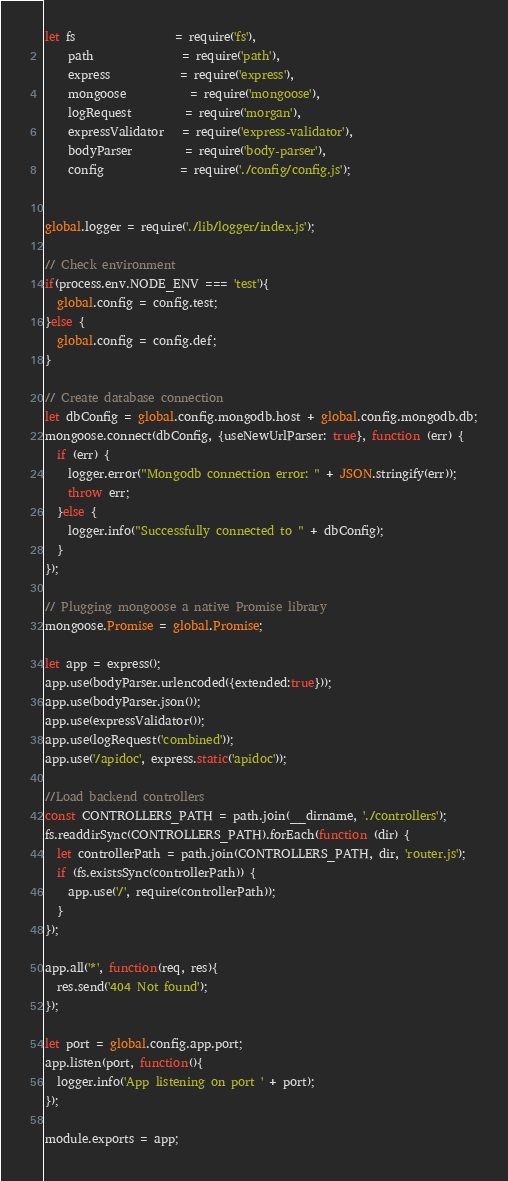Convert code to text. <code><loc_0><loc_0><loc_500><loc_500><_JavaScript_>let fs                 = require('fs'),
    path               = require('path'),
    express            = require('express'),
    mongoose           = require('mongoose'),
    logRequest         = require('morgan'),
    expressValidator   = require('express-validator'),
    bodyParser         = require('body-parser'),
    config             = require('./config/config.js');


global.logger = require('./lib/logger/index.js');

// Check environment
if(process.env.NODE_ENV === 'test'){
  global.config = config.test;
}else {
  global.config = config.def;
}

// Create database connection
let dbConfig = global.config.mongodb.host + global.config.mongodb.db;
mongoose.connect(dbConfig, {useNewUrlParser: true}, function (err) {
  if (err) {
    logger.error("Mongodb connection error: " + JSON.stringify(err));
    throw err;
  }else {
    logger.info("Successfully connected to " + dbConfig);
  }
});

// Plugging mongoose a native Promise library
mongoose.Promise = global.Promise;

let app = express();
app.use(bodyParser.urlencoded({extended:true}));
app.use(bodyParser.json());
app.use(expressValidator());
app.use(logRequest('combined'));
app.use('/apidoc', express.static('apidoc'));

//Load backend controllers
const CONTROLLERS_PATH = path.join(__dirname, './controllers');
fs.readdirSync(CONTROLLERS_PATH).forEach(function (dir) {
  let controllerPath = path.join(CONTROLLERS_PATH, dir, 'router.js');
  if (fs.existsSync(controllerPath)) {
    app.use('/', require(controllerPath));
  }
});

app.all('*', function(req, res){
  res.send('404 Not found');
});

let port = global.config.app.port;
app.listen(port, function(){
  logger.info('App listening on port ' + port);
});

module.exports = app;</code> 